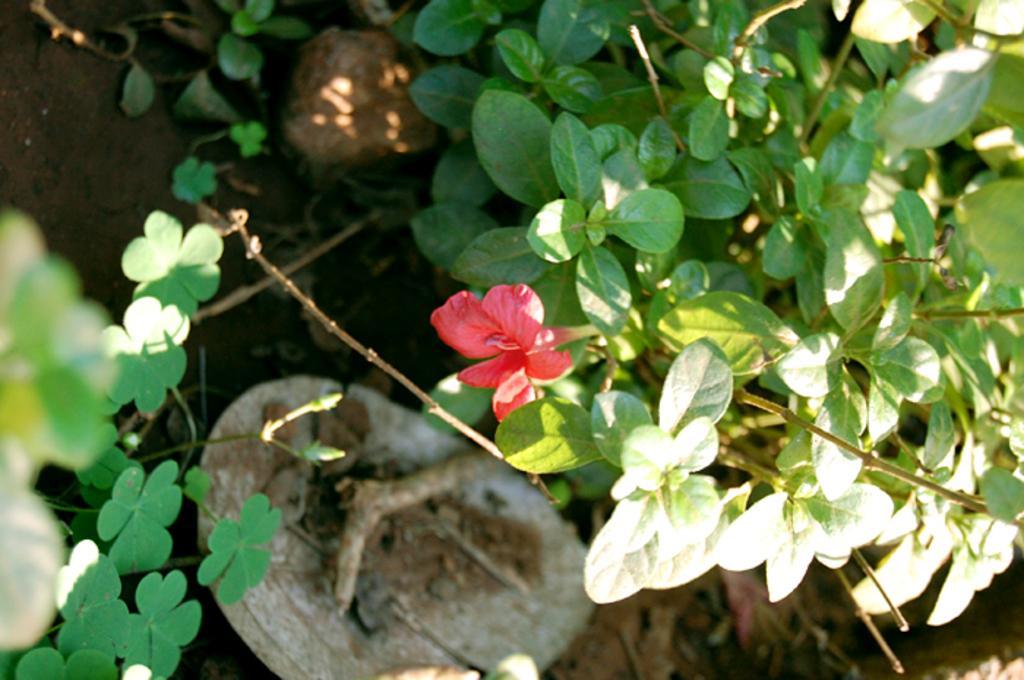Describe this image in one or two sentences. Here we see a plant with a flower on it. 